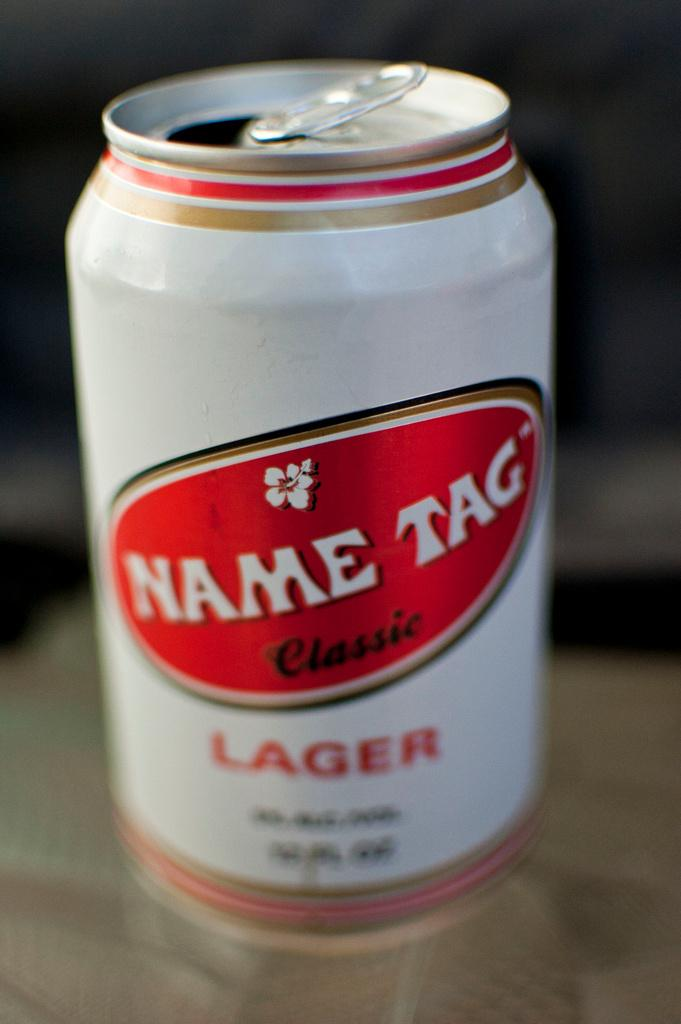<image>
Render a clear and concise summary of the photo. a can that has the word name on it 